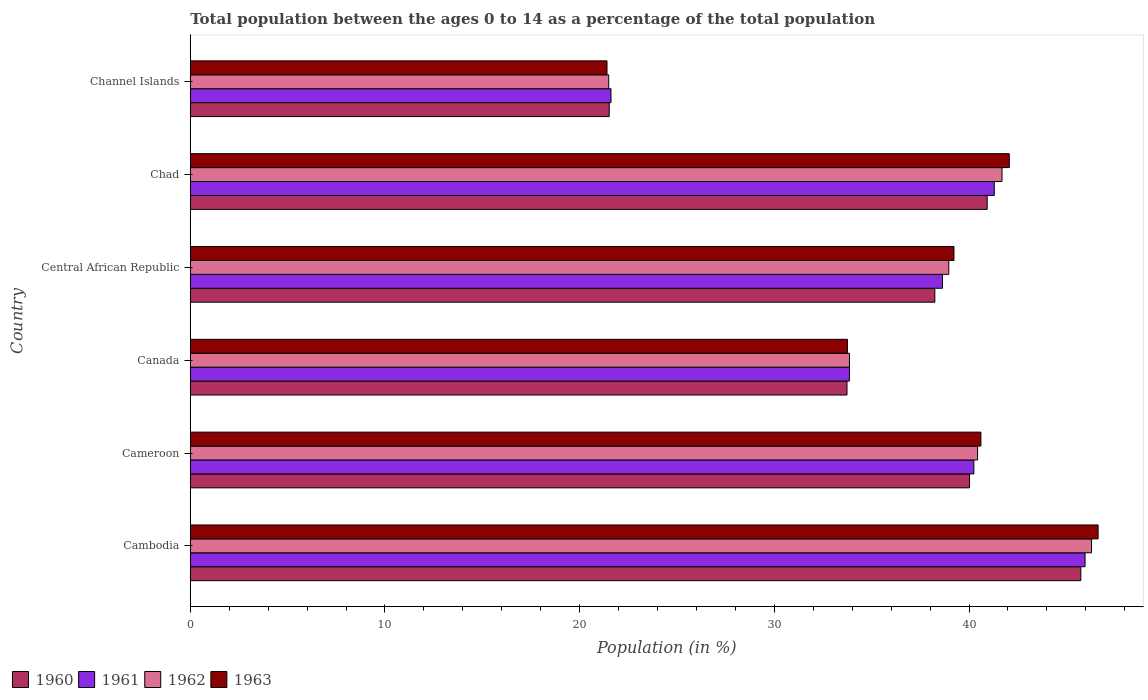How many different coloured bars are there?
Keep it short and to the point. 4. Are the number of bars per tick equal to the number of legend labels?
Your response must be concise. Yes. What is the label of the 6th group of bars from the top?
Provide a short and direct response. Cambodia. In how many cases, is the number of bars for a given country not equal to the number of legend labels?
Keep it short and to the point. 0. What is the percentage of the population ages 0 to 14 in 1962 in Cambodia?
Make the answer very short. 46.29. Across all countries, what is the maximum percentage of the population ages 0 to 14 in 1961?
Your response must be concise. 45.96. Across all countries, what is the minimum percentage of the population ages 0 to 14 in 1963?
Your answer should be compact. 21.41. In which country was the percentage of the population ages 0 to 14 in 1960 maximum?
Ensure brevity in your answer.  Cambodia. In which country was the percentage of the population ages 0 to 14 in 1963 minimum?
Your response must be concise. Channel Islands. What is the total percentage of the population ages 0 to 14 in 1960 in the graph?
Provide a short and direct response. 220.2. What is the difference between the percentage of the population ages 0 to 14 in 1960 in Cameroon and that in Channel Islands?
Offer a very short reply. 18.51. What is the difference between the percentage of the population ages 0 to 14 in 1960 in Chad and the percentage of the population ages 0 to 14 in 1963 in Channel Islands?
Make the answer very short. 19.53. What is the average percentage of the population ages 0 to 14 in 1962 per country?
Give a very brief answer. 37.12. What is the difference between the percentage of the population ages 0 to 14 in 1961 and percentage of the population ages 0 to 14 in 1960 in Cameroon?
Offer a very short reply. 0.22. In how many countries, is the percentage of the population ages 0 to 14 in 1960 greater than 42 ?
Offer a very short reply. 1. What is the ratio of the percentage of the population ages 0 to 14 in 1963 in Cambodia to that in Channel Islands?
Give a very brief answer. 2.18. Is the percentage of the population ages 0 to 14 in 1962 in Canada less than that in Central African Republic?
Provide a succinct answer. Yes. Is the difference between the percentage of the population ages 0 to 14 in 1961 in Canada and Central African Republic greater than the difference between the percentage of the population ages 0 to 14 in 1960 in Canada and Central African Republic?
Make the answer very short. No. What is the difference between the highest and the second highest percentage of the population ages 0 to 14 in 1963?
Make the answer very short. 4.56. What is the difference between the highest and the lowest percentage of the population ages 0 to 14 in 1960?
Offer a terse response. 24.22. In how many countries, is the percentage of the population ages 0 to 14 in 1960 greater than the average percentage of the population ages 0 to 14 in 1960 taken over all countries?
Your response must be concise. 4. Is the sum of the percentage of the population ages 0 to 14 in 1961 in Cameroon and Central African Republic greater than the maximum percentage of the population ages 0 to 14 in 1960 across all countries?
Provide a succinct answer. Yes. Is it the case that in every country, the sum of the percentage of the population ages 0 to 14 in 1963 and percentage of the population ages 0 to 14 in 1962 is greater than the sum of percentage of the population ages 0 to 14 in 1960 and percentage of the population ages 0 to 14 in 1961?
Provide a short and direct response. No. What does the 4th bar from the top in Canada represents?
Give a very brief answer. 1960. How many bars are there?
Make the answer very short. 24. Are all the bars in the graph horizontal?
Give a very brief answer. Yes. How many countries are there in the graph?
Your answer should be compact. 6. What is the difference between two consecutive major ticks on the X-axis?
Offer a terse response. 10. Does the graph contain grids?
Ensure brevity in your answer.  No. Where does the legend appear in the graph?
Give a very brief answer. Bottom left. What is the title of the graph?
Offer a terse response. Total population between the ages 0 to 14 as a percentage of the total population. Does "2005" appear as one of the legend labels in the graph?
Offer a very short reply. No. What is the label or title of the Y-axis?
Provide a short and direct response. Country. What is the Population (in %) in 1960 in Cambodia?
Your answer should be compact. 45.74. What is the Population (in %) of 1961 in Cambodia?
Your answer should be compact. 45.96. What is the Population (in %) in 1962 in Cambodia?
Ensure brevity in your answer.  46.29. What is the Population (in %) in 1963 in Cambodia?
Your answer should be very brief. 46.63. What is the Population (in %) of 1960 in Cameroon?
Keep it short and to the point. 40.03. What is the Population (in %) of 1961 in Cameroon?
Your response must be concise. 40.25. What is the Population (in %) of 1962 in Cameroon?
Provide a succinct answer. 40.44. What is the Population (in %) of 1963 in Cameroon?
Provide a succinct answer. 40.61. What is the Population (in %) of 1960 in Canada?
Offer a terse response. 33.73. What is the Population (in %) of 1961 in Canada?
Give a very brief answer. 33.86. What is the Population (in %) in 1962 in Canada?
Keep it short and to the point. 33.86. What is the Population (in %) of 1963 in Canada?
Offer a very short reply. 33.75. What is the Population (in %) in 1960 in Central African Republic?
Provide a short and direct response. 38.24. What is the Population (in %) of 1961 in Central African Republic?
Offer a terse response. 38.64. What is the Population (in %) of 1962 in Central African Republic?
Provide a short and direct response. 38.96. What is the Population (in %) in 1963 in Central African Republic?
Keep it short and to the point. 39.23. What is the Population (in %) in 1960 in Chad?
Your response must be concise. 40.93. What is the Population (in %) of 1961 in Chad?
Offer a terse response. 41.3. What is the Population (in %) of 1962 in Chad?
Make the answer very short. 41.7. What is the Population (in %) of 1963 in Chad?
Provide a succinct answer. 42.07. What is the Population (in %) of 1960 in Channel Islands?
Keep it short and to the point. 21.52. What is the Population (in %) in 1961 in Channel Islands?
Offer a terse response. 21.61. What is the Population (in %) in 1962 in Channel Islands?
Your answer should be very brief. 21.49. What is the Population (in %) of 1963 in Channel Islands?
Keep it short and to the point. 21.41. Across all countries, what is the maximum Population (in %) of 1960?
Your answer should be compact. 45.74. Across all countries, what is the maximum Population (in %) in 1961?
Make the answer very short. 45.96. Across all countries, what is the maximum Population (in %) of 1962?
Your answer should be compact. 46.29. Across all countries, what is the maximum Population (in %) in 1963?
Give a very brief answer. 46.63. Across all countries, what is the minimum Population (in %) of 1960?
Provide a succinct answer. 21.52. Across all countries, what is the minimum Population (in %) in 1961?
Your response must be concise. 21.61. Across all countries, what is the minimum Population (in %) in 1962?
Your answer should be compact. 21.49. Across all countries, what is the minimum Population (in %) in 1963?
Ensure brevity in your answer.  21.41. What is the total Population (in %) in 1960 in the graph?
Your answer should be compact. 220.2. What is the total Population (in %) of 1961 in the graph?
Your response must be concise. 221.61. What is the total Population (in %) of 1962 in the graph?
Provide a succinct answer. 222.74. What is the total Population (in %) in 1963 in the graph?
Make the answer very short. 223.7. What is the difference between the Population (in %) in 1960 in Cambodia and that in Cameroon?
Ensure brevity in your answer.  5.72. What is the difference between the Population (in %) in 1961 in Cambodia and that in Cameroon?
Provide a short and direct response. 5.71. What is the difference between the Population (in %) of 1962 in Cambodia and that in Cameroon?
Your answer should be very brief. 5.85. What is the difference between the Population (in %) of 1963 in Cambodia and that in Cameroon?
Make the answer very short. 6.02. What is the difference between the Population (in %) of 1960 in Cambodia and that in Canada?
Provide a succinct answer. 12.01. What is the difference between the Population (in %) in 1961 in Cambodia and that in Canada?
Provide a short and direct response. 12.11. What is the difference between the Population (in %) in 1962 in Cambodia and that in Canada?
Make the answer very short. 12.43. What is the difference between the Population (in %) in 1963 in Cambodia and that in Canada?
Your answer should be compact. 12.88. What is the difference between the Population (in %) in 1960 in Cambodia and that in Central African Republic?
Provide a succinct answer. 7.5. What is the difference between the Population (in %) of 1961 in Cambodia and that in Central African Republic?
Offer a terse response. 7.32. What is the difference between the Population (in %) of 1962 in Cambodia and that in Central African Republic?
Provide a succinct answer. 7.33. What is the difference between the Population (in %) in 1963 in Cambodia and that in Central African Republic?
Provide a short and direct response. 7.4. What is the difference between the Population (in %) of 1960 in Cambodia and that in Chad?
Offer a terse response. 4.81. What is the difference between the Population (in %) in 1961 in Cambodia and that in Chad?
Offer a very short reply. 4.67. What is the difference between the Population (in %) of 1962 in Cambodia and that in Chad?
Your answer should be compact. 4.6. What is the difference between the Population (in %) of 1963 in Cambodia and that in Chad?
Your answer should be very brief. 4.56. What is the difference between the Population (in %) in 1960 in Cambodia and that in Channel Islands?
Keep it short and to the point. 24.22. What is the difference between the Population (in %) of 1961 in Cambodia and that in Channel Islands?
Your answer should be very brief. 24.35. What is the difference between the Population (in %) of 1962 in Cambodia and that in Channel Islands?
Provide a short and direct response. 24.8. What is the difference between the Population (in %) of 1963 in Cambodia and that in Channel Islands?
Give a very brief answer. 25.23. What is the difference between the Population (in %) of 1960 in Cameroon and that in Canada?
Your answer should be very brief. 6.29. What is the difference between the Population (in %) of 1961 in Cameroon and that in Canada?
Provide a short and direct response. 6.39. What is the difference between the Population (in %) of 1962 in Cameroon and that in Canada?
Keep it short and to the point. 6.58. What is the difference between the Population (in %) in 1963 in Cameroon and that in Canada?
Provide a succinct answer. 6.86. What is the difference between the Population (in %) in 1960 in Cameroon and that in Central African Republic?
Your response must be concise. 1.78. What is the difference between the Population (in %) in 1961 in Cameroon and that in Central African Republic?
Offer a terse response. 1.61. What is the difference between the Population (in %) of 1962 in Cameroon and that in Central African Republic?
Your answer should be compact. 1.48. What is the difference between the Population (in %) in 1963 in Cameroon and that in Central African Republic?
Offer a terse response. 1.38. What is the difference between the Population (in %) in 1960 in Cameroon and that in Chad?
Your response must be concise. -0.91. What is the difference between the Population (in %) of 1961 in Cameroon and that in Chad?
Keep it short and to the point. -1.05. What is the difference between the Population (in %) in 1962 in Cameroon and that in Chad?
Provide a short and direct response. -1.25. What is the difference between the Population (in %) of 1963 in Cameroon and that in Chad?
Make the answer very short. -1.46. What is the difference between the Population (in %) in 1960 in Cameroon and that in Channel Islands?
Give a very brief answer. 18.51. What is the difference between the Population (in %) in 1961 in Cameroon and that in Channel Islands?
Your response must be concise. 18.64. What is the difference between the Population (in %) in 1962 in Cameroon and that in Channel Islands?
Give a very brief answer. 18.95. What is the difference between the Population (in %) in 1963 in Cameroon and that in Channel Islands?
Ensure brevity in your answer.  19.21. What is the difference between the Population (in %) in 1960 in Canada and that in Central African Republic?
Your answer should be compact. -4.51. What is the difference between the Population (in %) of 1961 in Canada and that in Central African Republic?
Make the answer very short. -4.78. What is the difference between the Population (in %) in 1962 in Canada and that in Central African Republic?
Your answer should be compact. -5.1. What is the difference between the Population (in %) in 1963 in Canada and that in Central African Republic?
Your answer should be very brief. -5.47. What is the difference between the Population (in %) of 1960 in Canada and that in Chad?
Make the answer very short. -7.2. What is the difference between the Population (in %) in 1961 in Canada and that in Chad?
Keep it short and to the point. -7.44. What is the difference between the Population (in %) of 1962 in Canada and that in Chad?
Ensure brevity in your answer.  -7.84. What is the difference between the Population (in %) of 1963 in Canada and that in Chad?
Offer a terse response. -8.32. What is the difference between the Population (in %) in 1960 in Canada and that in Channel Islands?
Your answer should be very brief. 12.21. What is the difference between the Population (in %) in 1961 in Canada and that in Channel Islands?
Provide a short and direct response. 12.25. What is the difference between the Population (in %) in 1962 in Canada and that in Channel Islands?
Ensure brevity in your answer.  12.37. What is the difference between the Population (in %) of 1963 in Canada and that in Channel Islands?
Your answer should be very brief. 12.35. What is the difference between the Population (in %) of 1960 in Central African Republic and that in Chad?
Ensure brevity in your answer.  -2.69. What is the difference between the Population (in %) of 1961 in Central African Republic and that in Chad?
Offer a very short reply. -2.66. What is the difference between the Population (in %) in 1962 in Central African Republic and that in Chad?
Your response must be concise. -2.73. What is the difference between the Population (in %) in 1963 in Central African Republic and that in Chad?
Your response must be concise. -2.84. What is the difference between the Population (in %) of 1960 in Central African Republic and that in Channel Islands?
Give a very brief answer. 16.73. What is the difference between the Population (in %) of 1961 in Central African Republic and that in Channel Islands?
Ensure brevity in your answer.  17.03. What is the difference between the Population (in %) of 1962 in Central African Republic and that in Channel Islands?
Your answer should be very brief. 17.47. What is the difference between the Population (in %) of 1963 in Central African Republic and that in Channel Islands?
Your answer should be compact. 17.82. What is the difference between the Population (in %) in 1960 in Chad and that in Channel Islands?
Your answer should be compact. 19.41. What is the difference between the Population (in %) of 1961 in Chad and that in Channel Islands?
Your response must be concise. 19.69. What is the difference between the Population (in %) in 1962 in Chad and that in Channel Islands?
Ensure brevity in your answer.  20.2. What is the difference between the Population (in %) in 1963 in Chad and that in Channel Islands?
Provide a short and direct response. 20.67. What is the difference between the Population (in %) in 1960 in Cambodia and the Population (in %) in 1961 in Cameroon?
Ensure brevity in your answer.  5.49. What is the difference between the Population (in %) of 1960 in Cambodia and the Population (in %) of 1962 in Cameroon?
Offer a very short reply. 5.3. What is the difference between the Population (in %) in 1960 in Cambodia and the Population (in %) in 1963 in Cameroon?
Give a very brief answer. 5.13. What is the difference between the Population (in %) of 1961 in Cambodia and the Population (in %) of 1962 in Cameroon?
Offer a terse response. 5.52. What is the difference between the Population (in %) in 1961 in Cambodia and the Population (in %) in 1963 in Cameroon?
Make the answer very short. 5.35. What is the difference between the Population (in %) in 1962 in Cambodia and the Population (in %) in 1963 in Cameroon?
Your answer should be very brief. 5.68. What is the difference between the Population (in %) of 1960 in Cambodia and the Population (in %) of 1961 in Canada?
Your answer should be very brief. 11.89. What is the difference between the Population (in %) of 1960 in Cambodia and the Population (in %) of 1962 in Canada?
Keep it short and to the point. 11.88. What is the difference between the Population (in %) of 1960 in Cambodia and the Population (in %) of 1963 in Canada?
Provide a short and direct response. 11.99. What is the difference between the Population (in %) of 1961 in Cambodia and the Population (in %) of 1962 in Canada?
Make the answer very short. 12.1. What is the difference between the Population (in %) of 1961 in Cambodia and the Population (in %) of 1963 in Canada?
Keep it short and to the point. 12.21. What is the difference between the Population (in %) of 1962 in Cambodia and the Population (in %) of 1963 in Canada?
Offer a very short reply. 12.54. What is the difference between the Population (in %) in 1960 in Cambodia and the Population (in %) in 1961 in Central African Republic?
Make the answer very short. 7.1. What is the difference between the Population (in %) of 1960 in Cambodia and the Population (in %) of 1962 in Central African Republic?
Provide a short and direct response. 6.78. What is the difference between the Population (in %) of 1960 in Cambodia and the Population (in %) of 1963 in Central African Republic?
Provide a short and direct response. 6.52. What is the difference between the Population (in %) in 1961 in Cambodia and the Population (in %) in 1962 in Central African Republic?
Offer a very short reply. 7. What is the difference between the Population (in %) in 1961 in Cambodia and the Population (in %) in 1963 in Central African Republic?
Make the answer very short. 6.73. What is the difference between the Population (in %) in 1962 in Cambodia and the Population (in %) in 1963 in Central African Republic?
Your answer should be very brief. 7.07. What is the difference between the Population (in %) in 1960 in Cambodia and the Population (in %) in 1961 in Chad?
Make the answer very short. 4.45. What is the difference between the Population (in %) in 1960 in Cambodia and the Population (in %) in 1962 in Chad?
Offer a very short reply. 4.05. What is the difference between the Population (in %) of 1960 in Cambodia and the Population (in %) of 1963 in Chad?
Provide a short and direct response. 3.67. What is the difference between the Population (in %) of 1961 in Cambodia and the Population (in %) of 1962 in Chad?
Offer a very short reply. 4.27. What is the difference between the Population (in %) in 1961 in Cambodia and the Population (in %) in 1963 in Chad?
Your answer should be very brief. 3.89. What is the difference between the Population (in %) in 1962 in Cambodia and the Population (in %) in 1963 in Chad?
Provide a succinct answer. 4.22. What is the difference between the Population (in %) in 1960 in Cambodia and the Population (in %) in 1961 in Channel Islands?
Ensure brevity in your answer.  24.13. What is the difference between the Population (in %) of 1960 in Cambodia and the Population (in %) of 1962 in Channel Islands?
Give a very brief answer. 24.25. What is the difference between the Population (in %) in 1960 in Cambodia and the Population (in %) in 1963 in Channel Islands?
Your response must be concise. 24.34. What is the difference between the Population (in %) of 1961 in Cambodia and the Population (in %) of 1962 in Channel Islands?
Your response must be concise. 24.47. What is the difference between the Population (in %) in 1961 in Cambodia and the Population (in %) in 1963 in Channel Islands?
Provide a succinct answer. 24.56. What is the difference between the Population (in %) of 1962 in Cambodia and the Population (in %) of 1963 in Channel Islands?
Offer a terse response. 24.89. What is the difference between the Population (in %) of 1960 in Cameroon and the Population (in %) of 1961 in Canada?
Offer a terse response. 6.17. What is the difference between the Population (in %) of 1960 in Cameroon and the Population (in %) of 1962 in Canada?
Provide a succinct answer. 6.17. What is the difference between the Population (in %) in 1960 in Cameroon and the Population (in %) in 1963 in Canada?
Ensure brevity in your answer.  6.27. What is the difference between the Population (in %) in 1961 in Cameroon and the Population (in %) in 1962 in Canada?
Offer a terse response. 6.39. What is the difference between the Population (in %) in 1961 in Cameroon and the Population (in %) in 1963 in Canada?
Your response must be concise. 6.5. What is the difference between the Population (in %) in 1962 in Cameroon and the Population (in %) in 1963 in Canada?
Your answer should be very brief. 6.69. What is the difference between the Population (in %) of 1960 in Cameroon and the Population (in %) of 1961 in Central African Republic?
Provide a short and direct response. 1.39. What is the difference between the Population (in %) of 1960 in Cameroon and the Population (in %) of 1962 in Central African Republic?
Offer a very short reply. 1.07. What is the difference between the Population (in %) in 1960 in Cameroon and the Population (in %) in 1963 in Central African Republic?
Offer a very short reply. 0.8. What is the difference between the Population (in %) of 1961 in Cameroon and the Population (in %) of 1962 in Central African Republic?
Provide a succinct answer. 1.29. What is the difference between the Population (in %) of 1961 in Cameroon and the Population (in %) of 1963 in Central African Republic?
Offer a terse response. 1.02. What is the difference between the Population (in %) in 1962 in Cameroon and the Population (in %) in 1963 in Central African Republic?
Keep it short and to the point. 1.21. What is the difference between the Population (in %) in 1960 in Cameroon and the Population (in %) in 1961 in Chad?
Your response must be concise. -1.27. What is the difference between the Population (in %) of 1960 in Cameroon and the Population (in %) of 1962 in Chad?
Ensure brevity in your answer.  -1.67. What is the difference between the Population (in %) of 1960 in Cameroon and the Population (in %) of 1963 in Chad?
Provide a succinct answer. -2.04. What is the difference between the Population (in %) of 1961 in Cameroon and the Population (in %) of 1962 in Chad?
Your response must be concise. -1.45. What is the difference between the Population (in %) in 1961 in Cameroon and the Population (in %) in 1963 in Chad?
Offer a terse response. -1.82. What is the difference between the Population (in %) of 1962 in Cameroon and the Population (in %) of 1963 in Chad?
Provide a short and direct response. -1.63. What is the difference between the Population (in %) in 1960 in Cameroon and the Population (in %) in 1961 in Channel Islands?
Keep it short and to the point. 18.42. What is the difference between the Population (in %) of 1960 in Cameroon and the Population (in %) of 1962 in Channel Islands?
Provide a short and direct response. 18.53. What is the difference between the Population (in %) of 1960 in Cameroon and the Population (in %) of 1963 in Channel Islands?
Offer a terse response. 18.62. What is the difference between the Population (in %) of 1961 in Cameroon and the Population (in %) of 1962 in Channel Islands?
Ensure brevity in your answer.  18.76. What is the difference between the Population (in %) of 1961 in Cameroon and the Population (in %) of 1963 in Channel Islands?
Ensure brevity in your answer.  18.84. What is the difference between the Population (in %) in 1962 in Cameroon and the Population (in %) in 1963 in Channel Islands?
Give a very brief answer. 19.04. What is the difference between the Population (in %) in 1960 in Canada and the Population (in %) in 1961 in Central African Republic?
Your answer should be compact. -4.91. What is the difference between the Population (in %) in 1960 in Canada and the Population (in %) in 1962 in Central African Republic?
Offer a terse response. -5.23. What is the difference between the Population (in %) in 1960 in Canada and the Population (in %) in 1963 in Central African Republic?
Your answer should be compact. -5.5. What is the difference between the Population (in %) of 1961 in Canada and the Population (in %) of 1962 in Central African Republic?
Your answer should be compact. -5.1. What is the difference between the Population (in %) in 1961 in Canada and the Population (in %) in 1963 in Central African Republic?
Provide a short and direct response. -5.37. What is the difference between the Population (in %) of 1962 in Canada and the Population (in %) of 1963 in Central African Republic?
Give a very brief answer. -5.37. What is the difference between the Population (in %) in 1960 in Canada and the Population (in %) in 1961 in Chad?
Make the answer very short. -7.56. What is the difference between the Population (in %) in 1960 in Canada and the Population (in %) in 1962 in Chad?
Provide a succinct answer. -7.96. What is the difference between the Population (in %) in 1960 in Canada and the Population (in %) in 1963 in Chad?
Your answer should be very brief. -8.34. What is the difference between the Population (in %) of 1961 in Canada and the Population (in %) of 1962 in Chad?
Keep it short and to the point. -7.84. What is the difference between the Population (in %) in 1961 in Canada and the Population (in %) in 1963 in Chad?
Provide a short and direct response. -8.21. What is the difference between the Population (in %) in 1962 in Canada and the Population (in %) in 1963 in Chad?
Your answer should be very brief. -8.21. What is the difference between the Population (in %) of 1960 in Canada and the Population (in %) of 1961 in Channel Islands?
Make the answer very short. 12.12. What is the difference between the Population (in %) in 1960 in Canada and the Population (in %) in 1962 in Channel Islands?
Your answer should be very brief. 12.24. What is the difference between the Population (in %) in 1960 in Canada and the Population (in %) in 1963 in Channel Islands?
Keep it short and to the point. 12.33. What is the difference between the Population (in %) in 1961 in Canada and the Population (in %) in 1962 in Channel Islands?
Your response must be concise. 12.36. What is the difference between the Population (in %) in 1961 in Canada and the Population (in %) in 1963 in Channel Islands?
Your answer should be very brief. 12.45. What is the difference between the Population (in %) in 1962 in Canada and the Population (in %) in 1963 in Channel Islands?
Make the answer very short. 12.45. What is the difference between the Population (in %) in 1960 in Central African Republic and the Population (in %) in 1961 in Chad?
Ensure brevity in your answer.  -3.05. What is the difference between the Population (in %) of 1960 in Central African Republic and the Population (in %) of 1962 in Chad?
Your answer should be compact. -3.45. What is the difference between the Population (in %) in 1960 in Central African Republic and the Population (in %) in 1963 in Chad?
Ensure brevity in your answer.  -3.83. What is the difference between the Population (in %) in 1961 in Central African Republic and the Population (in %) in 1962 in Chad?
Your answer should be very brief. -3.06. What is the difference between the Population (in %) in 1961 in Central African Republic and the Population (in %) in 1963 in Chad?
Give a very brief answer. -3.43. What is the difference between the Population (in %) in 1962 in Central African Republic and the Population (in %) in 1963 in Chad?
Offer a very short reply. -3.11. What is the difference between the Population (in %) of 1960 in Central African Republic and the Population (in %) of 1961 in Channel Islands?
Make the answer very short. 16.63. What is the difference between the Population (in %) of 1960 in Central African Republic and the Population (in %) of 1962 in Channel Islands?
Offer a very short reply. 16.75. What is the difference between the Population (in %) of 1960 in Central African Republic and the Population (in %) of 1963 in Channel Islands?
Provide a short and direct response. 16.84. What is the difference between the Population (in %) of 1961 in Central African Republic and the Population (in %) of 1962 in Channel Islands?
Provide a succinct answer. 17.15. What is the difference between the Population (in %) in 1961 in Central African Republic and the Population (in %) in 1963 in Channel Islands?
Your response must be concise. 17.23. What is the difference between the Population (in %) of 1962 in Central African Republic and the Population (in %) of 1963 in Channel Islands?
Offer a very short reply. 17.56. What is the difference between the Population (in %) of 1960 in Chad and the Population (in %) of 1961 in Channel Islands?
Offer a very short reply. 19.32. What is the difference between the Population (in %) of 1960 in Chad and the Population (in %) of 1962 in Channel Islands?
Give a very brief answer. 19.44. What is the difference between the Population (in %) in 1960 in Chad and the Population (in %) in 1963 in Channel Islands?
Keep it short and to the point. 19.53. What is the difference between the Population (in %) in 1961 in Chad and the Population (in %) in 1962 in Channel Islands?
Ensure brevity in your answer.  19.8. What is the difference between the Population (in %) of 1961 in Chad and the Population (in %) of 1963 in Channel Islands?
Offer a very short reply. 19.89. What is the difference between the Population (in %) in 1962 in Chad and the Population (in %) in 1963 in Channel Islands?
Offer a very short reply. 20.29. What is the average Population (in %) of 1960 per country?
Provide a succinct answer. 36.7. What is the average Population (in %) of 1961 per country?
Provide a short and direct response. 36.94. What is the average Population (in %) in 1962 per country?
Make the answer very short. 37.12. What is the average Population (in %) of 1963 per country?
Your answer should be very brief. 37.28. What is the difference between the Population (in %) in 1960 and Population (in %) in 1961 in Cambodia?
Offer a very short reply. -0.22. What is the difference between the Population (in %) in 1960 and Population (in %) in 1962 in Cambodia?
Ensure brevity in your answer.  -0.55. What is the difference between the Population (in %) of 1960 and Population (in %) of 1963 in Cambodia?
Your answer should be very brief. -0.89. What is the difference between the Population (in %) in 1961 and Population (in %) in 1962 in Cambodia?
Make the answer very short. -0.33. What is the difference between the Population (in %) of 1961 and Population (in %) of 1963 in Cambodia?
Offer a terse response. -0.67. What is the difference between the Population (in %) of 1962 and Population (in %) of 1963 in Cambodia?
Provide a short and direct response. -0.34. What is the difference between the Population (in %) in 1960 and Population (in %) in 1961 in Cameroon?
Ensure brevity in your answer.  -0.22. What is the difference between the Population (in %) of 1960 and Population (in %) of 1962 in Cameroon?
Make the answer very short. -0.41. What is the difference between the Population (in %) of 1960 and Population (in %) of 1963 in Cameroon?
Give a very brief answer. -0.58. What is the difference between the Population (in %) in 1961 and Population (in %) in 1962 in Cameroon?
Your answer should be very brief. -0.19. What is the difference between the Population (in %) in 1961 and Population (in %) in 1963 in Cameroon?
Ensure brevity in your answer.  -0.36. What is the difference between the Population (in %) in 1962 and Population (in %) in 1963 in Cameroon?
Keep it short and to the point. -0.17. What is the difference between the Population (in %) in 1960 and Population (in %) in 1961 in Canada?
Ensure brevity in your answer.  -0.12. What is the difference between the Population (in %) in 1960 and Population (in %) in 1962 in Canada?
Ensure brevity in your answer.  -0.13. What is the difference between the Population (in %) of 1960 and Population (in %) of 1963 in Canada?
Provide a short and direct response. -0.02. What is the difference between the Population (in %) in 1961 and Population (in %) in 1962 in Canada?
Offer a terse response. -0. What is the difference between the Population (in %) of 1961 and Population (in %) of 1963 in Canada?
Your answer should be compact. 0.1. What is the difference between the Population (in %) of 1962 and Population (in %) of 1963 in Canada?
Give a very brief answer. 0.11. What is the difference between the Population (in %) of 1960 and Population (in %) of 1961 in Central African Republic?
Give a very brief answer. -0.39. What is the difference between the Population (in %) of 1960 and Population (in %) of 1962 in Central African Republic?
Keep it short and to the point. -0.72. What is the difference between the Population (in %) in 1960 and Population (in %) in 1963 in Central African Republic?
Give a very brief answer. -0.98. What is the difference between the Population (in %) of 1961 and Population (in %) of 1962 in Central African Republic?
Your answer should be compact. -0.32. What is the difference between the Population (in %) in 1961 and Population (in %) in 1963 in Central African Republic?
Your answer should be compact. -0.59. What is the difference between the Population (in %) of 1962 and Population (in %) of 1963 in Central African Republic?
Provide a short and direct response. -0.27. What is the difference between the Population (in %) in 1960 and Population (in %) in 1961 in Chad?
Your answer should be compact. -0.36. What is the difference between the Population (in %) of 1960 and Population (in %) of 1962 in Chad?
Give a very brief answer. -0.76. What is the difference between the Population (in %) in 1960 and Population (in %) in 1963 in Chad?
Provide a succinct answer. -1.14. What is the difference between the Population (in %) of 1961 and Population (in %) of 1962 in Chad?
Offer a terse response. -0.4. What is the difference between the Population (in %) of 1961 and Population (in %) of 1963 in Chad?
Your answer should be very brief. -0.77. What is the difference between the Population (in %) of 1962 and Population (in %) of 1963 in Chad?
Provide a succinct answer. -0.38. What is the difference between the Population (in %) of 1960 and Population (in %) of 1961 in Channel Islands?
Provide a short and direct response. -0.09. What is the difference between the Population (in %) in 1960 and Population (in %) in 1962 in Channel Islands?
Offer a very short reply. 0.03. What is the difference between the Population (in %) of 1960 and Population (in %) of 1963 in Channel Islands?
Your answer should be compact. 0.11. What is the difference between the Population (in %) of 1961 and Population (in %) of 1962 in Channel Islands?
Offer a terse response. 0.12. What is the difference between the Population (in %) in 1961 and Population (in %) in 1963 in Channel Islands?
Offer a terse response. 0.2. What is the difference between the Population (in %) in 1962 and Population (in %) in 1963 in Channel Islands?
Your answer should be very brief. 0.09. What is the ratio of the Population (in %) of 1960 in Cambodia to that in Cameroon?
Provide a short and direct response. 1.14. What is the ratio of the Population (in %) of 1961 in Cambodia to that in Cameroon?
Give a very brief answer. 1.14. What is the ratio of the Population (in %) of 1962 in Cambodia to that in Cameroon?
Offer a very short reply. 1.14. What is the ratio of the Population (in %) of 1963 in Cambodia to that in Cameroon?
Keep it short and to the point. 1.15. What is the ratio of the Population (in %) of 1960 in Cambodia to that in Canada?
Offer a terse response. 1.36. What is the ratio of the Population (in %) of 1961 in Cambodia to that in Canada?
Your answer should be very brief. 1.36. What is the ratio of the Population (in %) in 1962 in Cambodia to that in Canada?
Your answer should be very brief. 1.37. What is the ratio of the Population (in %) of 1963 in Cambodia to that in Canada?
Provide a short and direct response. 1.38. What is the ratio of the Population (in %) of 1960 in Cambodia to that in Central African Republic?
Offer a very short reply. 1.2. What is the ratio of the Population (in %) in 1961 in Cambodia to that in Central African Republic?
Ensure brevity in your answer.  1.19. What is the ratio of the Population (in %) in 1962 in Cambodia to that in Central African Republic?
Give a very brief answer. 1.19. What is the ratio of the Population (in %) in 1963 in Cambodia to that in Central African Republic?
Make the answer very short. 1.19. What is the ratio of the Population (in %) of 1960 in Cambodia to that in Chad?
Keep it short and to the point. 1.12. What is the ratio of the Population (in %) in 1961 in Cambodia to that in Chad?
Your response must be concise. 1.11. What is the ratio of the Population (in %) in 1962 in Cambodia to that in Chad?
Give a very brief answer. 1.11. What is the ratio of the Population (in %) in 1963 in Cambodia to that in Chad?
Your answer should be very brief. 1.11. What is the ratio of the Population (in %) of 1960 in Cambodia to that in Channel Islands?
Your answer should be compact. 2.13. What is the ratio of the Population (in %) of 1961 in Cambodia to that in Channel Islands?
Keep it short and to the point. 2.13. What is the ratio of the Population (in %) of 1962 in Cambodia to that in Channel Islands?
Provide a short and direct response. 2.15. What is the ratio of the Population (in %) of 1963 in Cambodia to that in Channel Islands?
Offer a terse response. 2.18. What is the ratio of the Population (in %) of 1960 in Cameroon to that in Canada?
Ensure brevity in your answer.  1.19. What is the ratio of the Population (in %) in 1961 in Cameroon to that in Canada?
Offer a very short reply. 1.19. What is the ratio of the Population (in %) in 1962 in Cameroon to that in Canada?
Make the answer very short. 1.19. What is the ratio of the Population (in %) in 1963 in Cameroon to that in Canada?
Provide a succinct answer. 1.2. What is the ratio of the Population (in %) in 1960 in Cameroon to that in Central African Republic?
Give a very brief answer. 1.05. What is the ratio of the Population (in %) of 1961 in Cameroon to that in Central African Republic?
Your answer should be compact. 1.04. What is the ratio of the Population (in %) of 1962 in Cameroon to that in Central African Republic?
Keep it short and to the point. 1.04. What is the ratio of the Population (in %) in 1963 in Cameroon to that in Central African Republic?
Offer a terse response. 1.04. What is the ratio of the Population (in %) of 1960 in Cameroon to that in Chad?
Ensure brevity in your answer.  0.98. What is the ratio of the Population (in %) of 1961 in Cameroon to that in Chad?
Your answer should be compact. 0.97. What is the ratio of the Population (in %) in 1962 in Cameroon to that in Chad?
Provide a succinct answer. 0.97. What is the ratio of the Population (in %) of 1963 in Cameroon to that in Chad?
Offer a terse response. 0.97. What is the ratio of the Population (in %) in 1960 in Cameroon to that in Channel Islands?
Provide a succinct answer. 1.86. What is the ratio of the Population (in %) in 1961 in Cameroon to that in Channel Islands?
Keep it short and to the point. 1.86. What is the ratio of the Population (in %) of 1962 in Cameroon to that in Channel Islands?
Provide a short and direct response. 1.88. What is the ratio of the Population (in %) of 1963 in Cameroon to that in Channel Islands?
Offer a terse response. 1.9. What is the ratio of the Population (in %) of 1960 in Canada to that in Central African Republic?
Your answer should be very brief. 0.88. What is the ratio of the Population (in %) of 1961 in Canada to that in Central African Republic?
Your answer should be compact. 0.88. What is the ratio of the Population (in %) in 1962 in Canada to that in Central African Republic?
Provide a short and direct response. 0.87. What is the ratio of the Population (in %) of 1963 in Canada to that in Central African Republic?
Keep it short and to the point. 0.86. What is the ratio of the Population (in %) in 1960 in Canada to that in Chad?
Provide a short and direct response. 0.82. What is the ratio of the Population (in %) of 1961 in Canada to that in Chad?
Your answer should be compact. 0.82. What is the ratio of the Population (in %) of 1962 in Canada to that in Chad?
Give a very brief answer. 0.81. What is the ratio of the Population (in %) in 1963 in Canada to that in Chad?
Make the answer very short. 0.8. What is the ratio of the Population (in %) of 1960 in Canada to that in Channel Islands?
Make the answer very short. 1.57. What is the ratio of the Population (in %) in 1961 in Canada to that in Channel Islands?
Your answer should be very brief. 1.57. What is the ratio of the Population (in %) in 1962 in Canada to that in Channel Islands?
Keep it short and to the point. 1.58. What is the ratio of the Population (in %) in 1963 in Canada to that in Channel Islands?
Give a very brief answer. 1.58. What is the ratio of the Population (in %) of 1960 in Central African Republic to that in Chad?
Ensure brevity in your answer.  0.93. What is the ratio of the Population (in %) of 1961 in Central African Republic to that in Chad?
Offer a terse response. 0.94. What is the ratio of the Population (in %) in 1962 in Central African Republic to that in Chad?
Offer a terse response. 0.93. What is the ratio of the Population (in %) of 1963 in Central African Republic to that in Chad?
Make the answer very short. 0.93. What is the ratio of the Population (in %) of 1960 in Central African Republic to that in Channel Islands?
Provide a short and direct response. 1.78. What is the ratio of the Population (in %) in 1961 in Central African Republic to that in Channel Islands?
Offer a terse response. 1.79. What is the ratio of the Population (in %) in 1962 in Central African Republic to that in Channel Islands?
Your response must be concise. 1.81. What is the ratio of the Population (in %) of 1963 in Central African Republic to that in Channel Islands?
Your answer should be very brief. 1.83. What is the ratio of the Population (in %) of 1960 in Chad to that in Channel Islands?
Offer a very short reply. 1.9. What is the ratio of the Population (in %) of 1961 in Chad to that in Channel Islands?
Your answer should be very brief. 1.91. What is the ratio of the Population (in %) in 1962 in Chad to that in Channel Islands?
Make the answer very short. 1.94. What is the ratio of the Population (in %) in 1963 in Chad to that in Channel Islands?
Your answer should be very brief. 1.97. What is the difference between the highest and the second highest Population (in %) of 1960?
Offer a terse response. 4.81. What is the difference between the highest and the second highest Population (in %) of 1961?
Keep it short and to the point. 4.67. What is the difference between the highest and the second highest Population (in %) in 1962?
Offer a terse response. 4.6. What is the difference between the highest and the second highest Population (in %) of 1963?
Ensure brevity in your answer.  4.56. What is the difference between the highest and the lowest Population (in %) in 1960?
Provide a short and direct response. 24.22. What is the difference between the highest and the lowest Population (in %) of 1961?
Provide a short and direct response. 24.35. What is the difference between the highest and the lowest Population (in %) in 1962?
Give a very brief answer. 24.8. What is the difference between the highest and the lowest Population (in %) of 1963?
Ensure brevity in your answer.  25.23. 